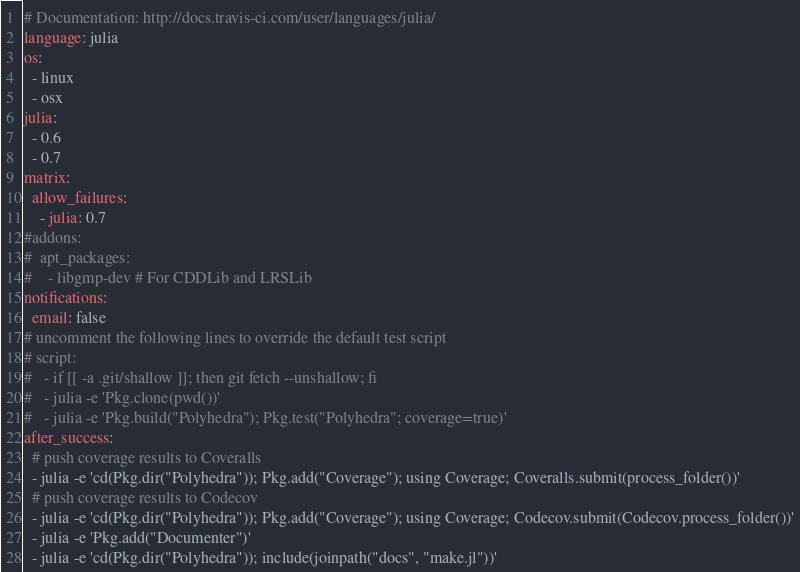<code> <loc_0><loc_0><loc_500><loc_500><_YAML_># Documentation: http://docs.travis-ci.com/user/languages/julia/
language: julia
os:
  - linux
  - osx
julia:
  - 0.6
  - 0.7
matrix:
  allow_failures:
    - julia: 0.7
#addons:
#  apt_packages:
#    - libgmp-dev # For CDDLib and LRSLib
notifications:
  email: false
# uncomment the following lines to override the default test script
# script:
#   - if [[ -a .git/shallow ]]; then git fetch --unshallow; fi
#   - julia -e 'Pkg.clone(pwd())'
#   - julia -e 'Pkg.build("Polyhedra"); Pkg.test("Polyhedra"; coverage=true)'
after_success:
  # push coverage results to Coveralls
  - julia -e 'cd(Pkg.dir("Polyhedra")); Pkg.add("Coverage"); using Coverage; Coveralls.submit(process_folder())'
  # push coverage results to Codecov
  - julia -e 'cd(Pkg.dir("Polyhedra")); Pkg.add("Coverage"); using Coverage; Codecov.submit(Codecov.process_folder())'
  - julia -e 'Pkg.add("Documenter")'
  - julia -e 'cd(Pkg.dir("Polyhedra")); include(joinpath("docs", "make.jl"))'
</code> 